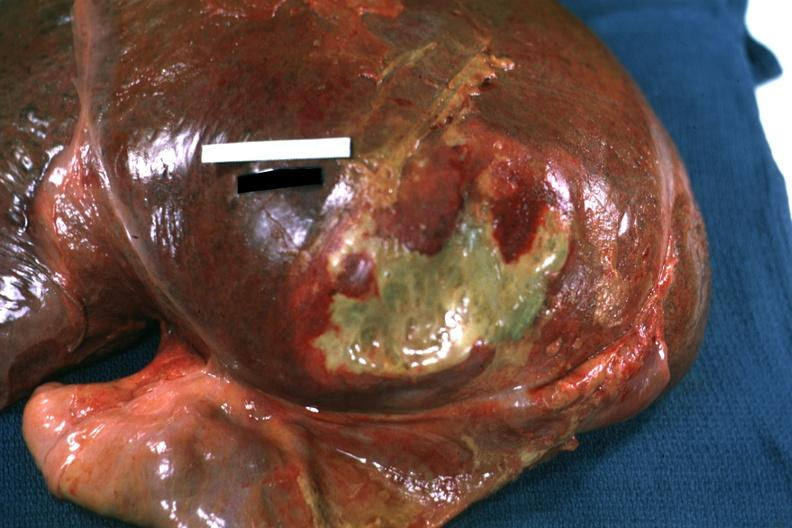s malignant thymoma reflected to show flat mass of yellow green pus quite good example?
Answer the question using a single word or phrase. No 